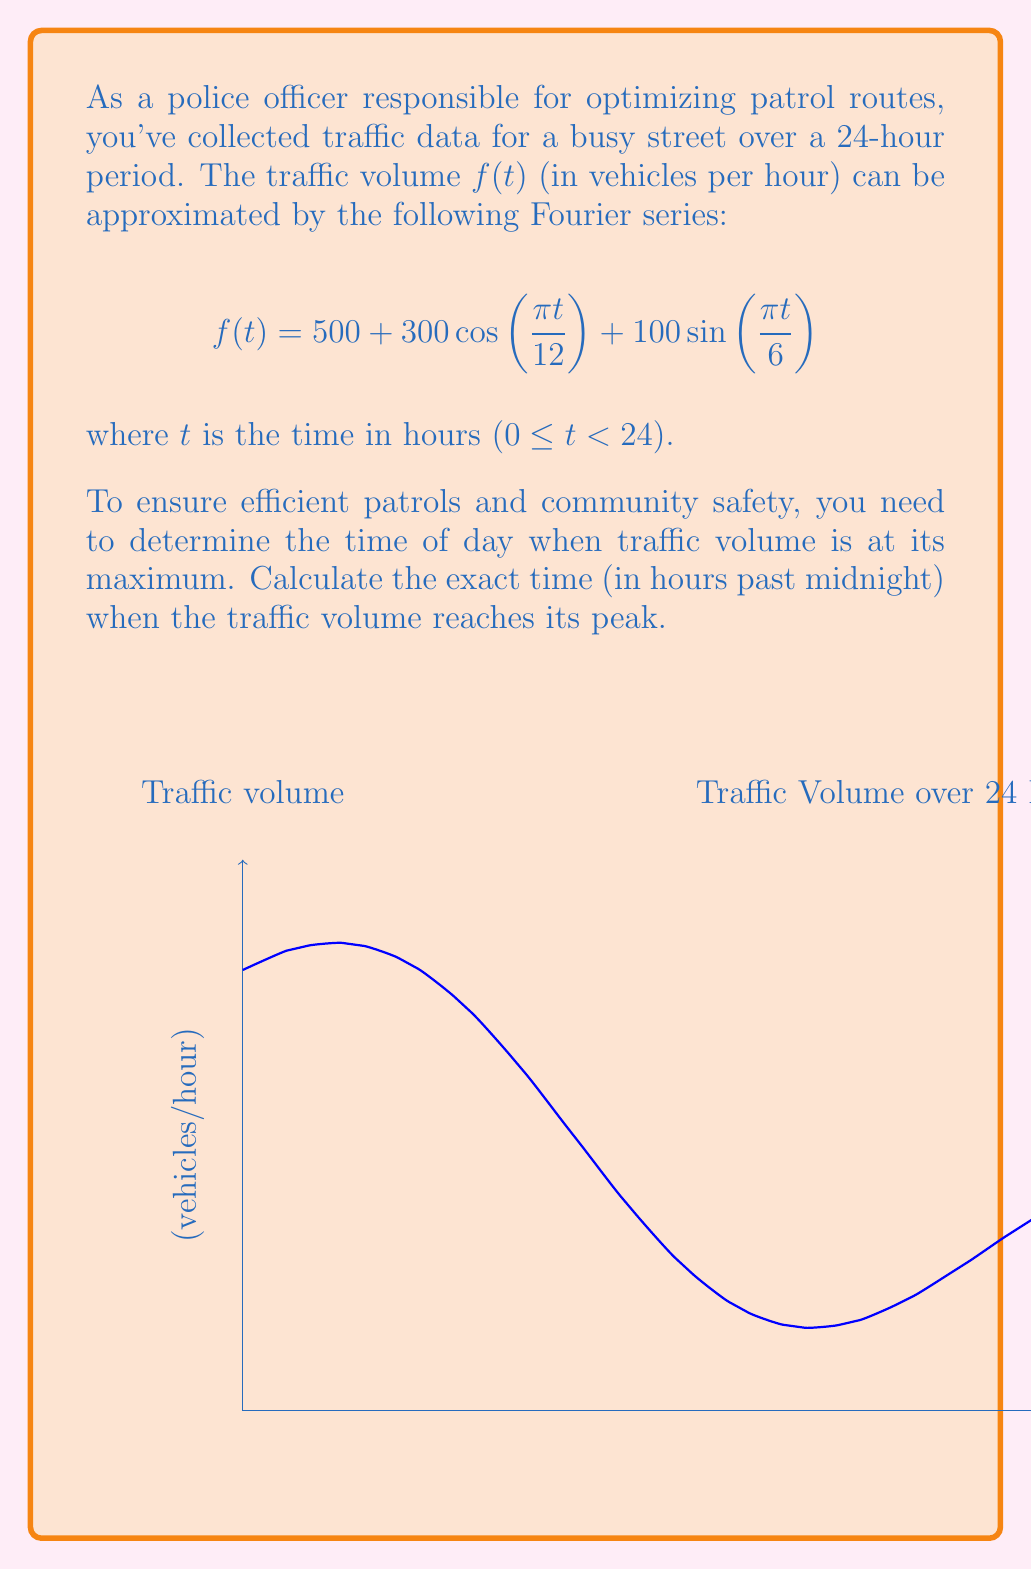Provide a solution to this math problem. To find the maximum traffic volume, we need to determine when the derivative of $f(t)$ equals zero:

1) First, let's calculate $f'(t)$:
   $$f'(t) = -300 \cdot \frac{\pi}{12} \sin(\frac{\pi t}{12}) + 100 \cdot \frac{\pi}{6} \cos(\frac{\pi t}{6})$$
   $$f'(t) = -25\pi \sin(\frac{\pi t}{12}) + \frac{50\pi}{3} \cos(\frac{\pi t}{6})$$

2) Set $f'(t) = 0$:
   $$-25\pi \sin(\frac{\pi t}{12}) + \frac{50\pi}{3} \cos(\frac{\pi t}{6}) = 0$$

3) Divide both sides by $\pi$:
   $$-25 \sin(\frac{\pi t}{12}) + \frac{50}{3} \cos(\frac{\pi t}{6}) = 0$$

4) Use the trigonometric identity $\cos(2x) = 1 - 2\sin^2(x)$:
   $$-25 \sin(\frac{\pi t}{12}) + \frac{50}{3} (1 - 2\sin^2(\frac{\pi t}{12})) = 0$$

5) Simplify:
   $$-25 \sin(\frac{\pi t}{12}) + \frac{50}{3} - \frac{100}{3}\sin^2(\frac{\pi t}{12}) = 0$$

6) Let $x = \sin(\frac{\pi t}{12})$. Then our equation becomes:
   $$-25x + \frac{50}{3} - \frac{100}{3}x^2 = 0$$

7) Multiply by 3:
   $$-75x + 50 - 100x^2 = 0$$

8) Rearrange to standard quadratic form:
   $$100x^2 + 75x - 50 = 0$$

9) Solve using the quadratic formula $x = \frac{-b \pm \sqrt{b^2 - 4ac}}{2a}$:
   $$x = \frac{-75 \pm \sqrt{75^2 + 4(100)(50)}}{2(100)}$$
   $$x = \frac{-75 \pm \sqrt{5625 + 20000}}{200} = \frac{-75 \pm \sqrt{25625}}{200}$$
   $$x = \frac{-75 \pm 160.08}{200}$$

10) This gives us two solutions: $x_1 = 0.4254$ and $x_2 = -0.8754$
    Since $\sin(\frac{\pi t}{12})$ must be between -1 and 1, both solutions are valid.

11) Solve for $t$:
    $$t_1 = \frac{12}{\pi} \arcsin(0.4254) \approx 2.76 \text{ hours}$$
    $$t_2 = \frac{12}{\pi} \arcsin(-0.8754) \approx 18.76 \text{ hours}$$

12) Evaluate $f(t)$ at both points to determine which gives the maximum:
    $$f(2.76) \approx 926.5 \text{ vehicles/hour}$$
    $$f(18.76) \approx 73.5 \text{ vehicles/hour}$$

Therefore, the maximum traffic volume occurs at approximately 2.76 hours past midnight.
Answer: 2.76 hours past midnight 